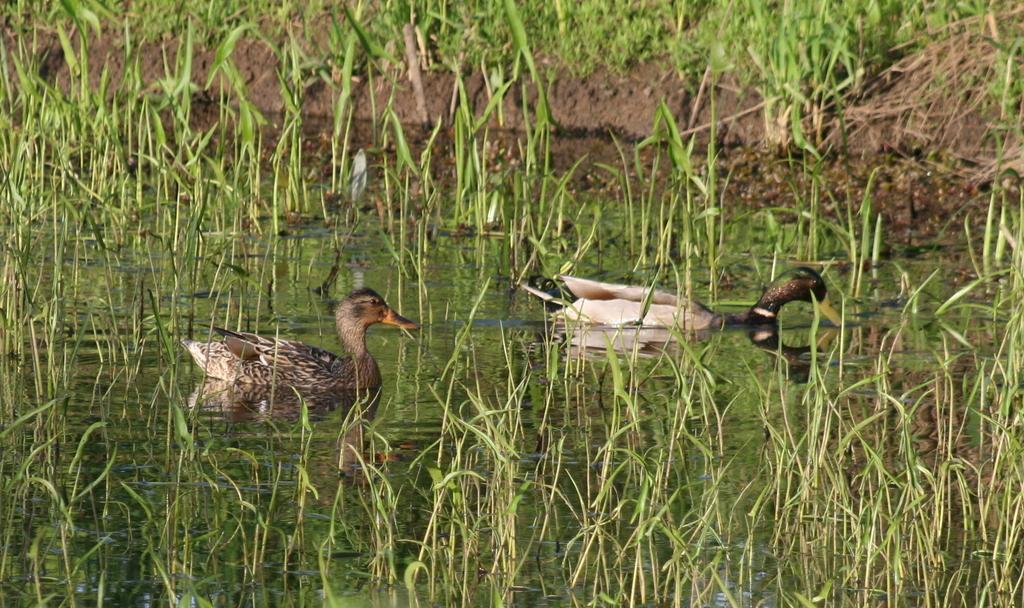Describe this image in one or two sentences. In this image, in the middle there are two ducks. At the bottom there are grass, plants, water. At the top there are plants, grass and land. 